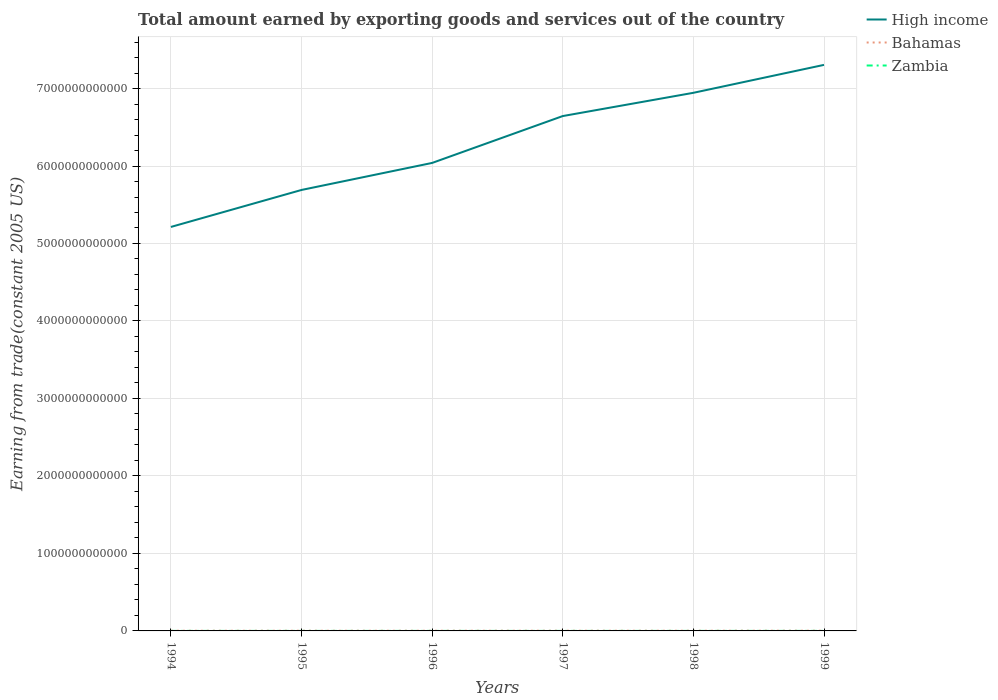Does the line corresponding to Bahamas intersect with the line corresponding to Zambia?
Provide a succinct answer. No. Is the number of lines equal to the number of legend labels?
Your response must be concise. Yes. Across all years, what is the maximum total amount earned by exporting goods and services in Zambia?
Ensure brevity in your answer.  1.79e+08. What is the total total amount earned by exporting goods and services in Bahamas in the graph?
Your response must be concise. -5.04e+08. What is the difference between the highest and the second highest total amount earned by exporting goods and services in Zambia?
Give a very brief answer. 2.86e+08. Is the total amount earned by exporting goods and services in Bahamas strictly greater than the total amount earned by exporting goods and services in Zambia over the years?
Offer a terse response. No. How many years are there in the graph?
Keep it short and to the point. 6. What is the difference between two consecutive major ticks on the Y-axis?
Provide a short and direct response. 1.00e+12. Are the values on the major ticks of Y-axis written in scientific E-notation?
Offer a terse response. No. Does the graph contain any zero values?
Provide a short and direct response. No. Does the graph contain grids?
Ensure brevity in your answer.  Yes. Where does the legend appear in the graph?
Ensure brevity in your answer.  Top right. How are the legend labels stacked?
Make the answer very short. Vertical. What is the title of the graph?
Offer a very short reply. Total amount earned by exporting goods and services out of the country. What is the label or title of the X-axis?
Your response must be concise. Years. What is the label or title of the Y-axis?
Offer a very short reply. Earning from trade(constant 2005 US). What is the Earning from trade(constant 2005 US) of High income in 1994?
Ensure brevity in your answer.  5.21e+12. What is the Earning from trade(constant 2005 US) in Bahamas in 1994?
Give a very brief answer. 2.35e+09. What is the Earning from trade(constant 2005 US) in Zambia in 1994?
Your answer should be compact. 2.00e+08. What is the Earning from trade(constant 2005 US) in High income in 1995?
Keep it short and to the point. 5.69e+12. What is the Earning from trade(constant 2005 US) of Bahamas in 1995?
Provide a succinct answer. 2.41e+09. What is the Earning from trade(constant 2005 US) of Zambia in 1995?
Provide a short and direct response. 1.79e+08. What is the Earning from trade(constant 2005 US) of High income in 1996?
Keep it short and to the point. 6.04e+12. What is the Earning from trade(constant 2005 US) in Bahamas in 1996?
Your answer should be compact. 2.50e+09. What is the Earning from trade(constant 2005 US) of Zambia in 1996?
Offer a very short reply. 2.01e+08. What is the Earning from trade(constant 2005 US) in High income in 1997?
Ensure brevity in your answer.  6.64e+12. What is the Earning from trade(constant 2005 US) in Bahamas in 1997?
Offer a terse response. 2.71e+09. What is the Earning from trade(constant 2005 US) of Zambia in 1997?
Your response must be concise. 2.37e+08. What is the Earning from trade(constant 2005 US) in High income in 1998?
Give a very brief answer. 6.94e+12. What is the Earning from trade(constant 2005 US) of Bahamas in 1998?
Offer a very short reply. 2.68e+09. What is the Earning from trade(constant 2005 US) of Zambia in 1998?
Offer a very short reply. 2.49e+08. What is the Earning from trade(constant 2005 US) in High income in 1999?
Your response must be concise. 7.31e+12. What is the Earning from trade(constant 2005 US) in Bahamas in 1999?
Make the answer very short. 2.85e+09. What is the Earning from trade(constant 2005 US) in Zambia in 1999?
Give a very brief answer. 4.66e+08. Across all years, what is the maximum Earning from trade(constant 2005 US) in High income?
Your answer should be compact. 7.31e+12. Across all years, what is the maximum Earning from trade(constant 2005 US) of Bahamas?
Provide a short and direct response. 2.85e+09. Across all years, what is the maximum Earning from trade(constant 2005 US) of Zambia?
Offer a very short reply. 4.66e+08. Across all years, what is the minimum Earning from trade(constant 2005 US) in High income?
Keep it short and to the point. 5.21e+12. Across all years, what is the minimum Earning from trade(constant 2005 US) in Bahamas?
Give a very brief answer. 2.35e+09. Across all years, what is the minimum Earning from trade(constant 2005 US) in Zambia?
Your response must be concise. 1.79e+08. What is the total Earning from trade(constant 2005 US) in High income in the graph?
Make the answer very short. 3.78e+13. What is the total Earning from trade(constant 2005 US) of Bahamas in the graph?
Keep it short and to the point. 1.55e+1. What is the total Earning from trade(constant 2005 US) of Zambia in the graph?
Your answer should be compact. 1.53e+09. What is the difference between the Earning from trade(constant 2005 US) in High income in 1994 and that in 1995?
Your answer should be very brief. -4.77e+11. What is the difference between the Earning from trade(constant 2005 US) in Bahamas in 1994 and that in 1995?
Your response must be concise. -6.07e+07. What is the difference between the Earning from trade(constant 2005 US) in Zambia in 1994 and that in 1995?
Provide a short and direct response. 2.11e+07. What is the difference between the Earning from trade(constant 2005 US) of High income in 1994 and that in 1996?
Provide a short and direct response. -8.26e+11. What is the difference between the Earning from trade(constant 2005 US) in Bahamas in 1994 and that in 1996?
Your answer should be compact. -1.48e+08. What is the difference between the Earning from trade(constant 2005 US) in Zambia in 1994 and that in 1996?
Provide a succinct answer. -4.14e+05. What is the difference between the Earning from trade(constant 2005 US) of High income in 1994 and that in 1997?
Offer a very short reply. -1.43e+12. What is the difference between the Earning from trade(constant 2005 US) in Bahamas in 1994 and that in 1997?
Give a very brief answer. -3.59e+08. What is the difference between the Earning from trade(constant 2005 US) in Zambia in 1994 and that in 1997?
Offer a very short reply. -3.68e+07. What is the difference between the Earning from trade(constant 2005 US) in High income in 1994 and that in 1998?
Provide a succinct answer. -1.73e+12. What is the difference between the Earning from trade(constant 2005 US) in Bahamas in 1994 and that in 1998?
Provide a short and direct response. -3.25e+08. What is the difference between the Earning from trade(constant 2005 US) of Zambia in 1994 and that in 1998?
Offer a very short reply. -4.81e+07. What is the difference between the Earning from trade(constant 2005 US) in High income in 1994 and that in 1999?
Offer a terse response. -2.09e+12. What is the difference between the Earning from trade(constant 2005 US) of Bahamas in 1994 and that in 1999?
Make the answer very short. -5.04e+08. What is the difference between the Earning from trade(constant 2005 US) in Zambia in 1994 and that in 1999?
Give a very brief answer. -2.65e+08. What is the difference between the Earning from trade(constant 2005 US) of High income in 1995 and that in 1996?
Your answer should be very brief. -3.49e+11. What is the difference between the Earning from trade(constant 2005 US) of Bahamas in 1995 and that in 1996?
Offer a terse response. -8.72e+07. What is the difference between the Earning from trade(constant 2005 US) of Zambia in 1995 and that in 1996?
Provide a short and direct response. -2.15e+07. What is the difference between the Earning from trade(constant 2005 US) in High income in 1995 and that in 1997?
Provide a short and direct response. -9.54e+11. What is the difference between the Earning from trade(constant 2005 US) of Bahamas in 1995 and that in 1997?
Ensure brevity in your answer.  -2.98e+08. What is the difference between the Earning from trade(constant 2005 US) in Zambia in 1995 and that in 1997?
Make the answer very short. -5.79e+07. What is the difference between the Earning from trade(constant 2005 US) in High income in 1995 and that in 1998?
Provide a short and direct response. -1.25e+12. What is the difference between the Earning from trade(constant 2005 US) in Bahamas in 1995 and that in 1998?
Your response must be concise. -2.65e+08. What is the difference between the Earning from trade(constant 2005 US) in Zambia in 1995 and that in 1998?
Your answer should be very brief. -6.91e+07. What is the difference between the Earning from trade(constant 2005 US) of High income in 1995 and that in 1999?
Provide a short and direct response. -1.61e+12. What is the difference between the Earning from trade(constant 2005 US) in Bahamas in 1995 and that in 1999?
Your answer should be very brief. -4.43e+08. What is the difference between the Earning from trade(constant 2005 US) of Zambia in 1995 and that in 1999?
Your answer should be very brief. -2.86e+08. What is the difference between the Earning from trade(constant 2005 US) in High income in 1996 and that in 1997?
Keep it short and to the point. -6.05e+11. What is the difference between the Earning from trade(constant 2005 US) of Bahamas in 1996 and that in 1997?
Provide a short and direct response. -2.11e+08. What is the difference between the Earning from trade(constant 2005 US) of Zambia in 1996 and that in 1997?
Provide a succinct answer. -3.64e+07. What is the difference between the Earning from trade(constant 2005 US) of High income in 1996 and that in 1998?
Your answer should be compact. -9.05e+11. What is the difference between the Earning from trade(constant 2005 US) in Bahamas in 1996 and that in 1998?
Offer a terse response. -1.78e+08. What is the difference between the Earning from trade(constant 2005 US) in Zambia in 1996 and that in 1998?
Keep it short and to the point. -4.77e+07. What is the difference between the Earning from trade(constant 2005 US) of High income in 1996 and that in 1999?
Provide a short and direct response. -1.27e+12. What is the difference between the Earning from trade(constant 2005 US) in Bahamas in 1996 and that in 1999?
Your response must be concise. -3.56e+08. What is the difference between the Earning from trade(constant 2005 US) in Zambia in 1996 and that in 1999?
Provide a succinct answer. -2.65e+08. What is the difference between the Earning from trade(constant 2005 US) of High income in 1997 and that in 1998?
Your answer should be very brief. -3.00e+11. What is the difference between the Earning from trade(constant 2005 US) in Bahamas in 1997 and that in 1998?
Provide a succinct answer. 3.35e+07. What is the difference between the Earning from trade(constant 2005 US) of Zambia in 1997 and that in 1998?
Ensure brevity in your answer.  -1.12e+07. What is the difference between the Earning from trade(constant 2005 US) in High income in 1997 and that in 1999?
Make the answer very short. -6.61e+11. What is the difference between the Earning from trade(constant 2005 US) in Bahamas in 1997 and that in 1999?
Give a very brief answer. -1.45e+08. What is the difference between the Earning from trade(constant 2005 US) in Zambia in 1997 and that in 1999?
Give a very brief answer. -2.29e+08. What is the difference between the Earning from trade(constant 2005 US) in High income in 1998 and that in 1999?
Your answer should be compact. -3.60e+11. What is the difference between the Earning from trade(constant 2005 US) of Bahamas in 1998 and that in 1999?
Provide a succinct answer. -1.79e+08. What is the difference between the Earning from trade(constant 2005 US) of Zambia in 1998 and that in 1999?
Keep it short and to the point. -2.17e+08. What is the difference between the Earning from trade(constant 2005 US) in High income in 1994 and the Earning from trade(constant 2005 US) in Bahamas in 1995?
Make the answer very short. 5.21e+12. What is the difference between the Earning from trade(constant 2005 US) in High income in 1994 and the Earning from trade(constant 2005 US) in Zambia in 1995?
Your answer should be compact. 5.21e+12. What is the difference between the Earning from trade(constant 2005 US) in Bahamas in 1994 and the Earning from trade(constant 2005 US) in Zambia in 1995?
Give a very brief answer. 2.17e+09. What is the difference between the Earning from trade(constant 2005 US) of High income in 1994 and the Earning from trade(constant 2005 US) of Bahamas in 1996?
Keep it short and to the point. 5.21e+12. What is the difference between the Earning from trade(constant 2005 US) in High income in 1994 and the Earning from trade(constant 2005 US) in Zambia in 1996?
Provide a succinct answer. 5.21e+12. What is the difference between the Earning from trade(constant 2005 US) in Bahamas in 1994 and the Earning from trade(constant 2005 US) in Zambia in 1996?
Offer a terse response. 2.15e+09. What is the difference between the Earning from trade(constant 2005 US) of High income in 1994 and the Earning from trade(constant 2005 US) of Bahamas in 1997?
Your answer should be compact. 5.21e+12. What is the difference between the Earning from trade(constant 2005 US) in High income in 1994 and the Earning from trade(constant 2005 US) in Zambia in 1997?
Offer a terse response. 5.21e+12. What is the difference between the Earning from trade(constant 2005 US) of Bahamas in 1994 and the Earning from trade(constant 2005 US) of Zambia in 1997?
Give a very brief answer. 2.11e+09. What is the difference between the Earning from trade(constant 2005 US) in High income in 1994 and the Earning from trade(constant 2005 US) in Bahamas in 1998?
Your response must be concise. 5.21e+12. What is the difference between the Earning from trade(constant 2005 US) in High income in 1994 and the Earning from trade(constant 2005 US) in Zambia in 1998?
Provide a short and direct response. 5.21e+12. What is the difference between the Earning from trade(constant 2005 US) of Bahamas in 1994 and the Earning from trade(constant 2005 US) of Zambia in 1998?
Your answer should be very brief. 2.10e+09. What is the difference between the Earning from trade(constant 2005 US) of High income in 1994 and the Earning from trade(constant 2005 US) of Bahamas in 1999?
Your answer should be very brief. 5.21e+12. What is the difference between the Earning from trade(constant 2005 US) in High income in 1994 and the Earning from trade(constant 2005 US) in Zambia in 1999?
Offer a terse response. 5.21e+12. What is the difference between the Earning from trade(constant 2005 US) in Bahamas in 1994 and the Earning from trade(constant 2005 US) in Zambia in 1999?
Your response must be concise. 1.88e+09. What is the difference between the Earning from trade(constant 2005 US) in High income in 1995 and the Earning from trade(constant 2005 US) in Bahamas in 1996?
Your response must be concise. 5.69e+12. What is the difference between the Earning from trade(constant 2005 US) in High income in 1995 and the Earning from trade(constant 2005 US) in Zambia in 1996?
Your answer should be compact. 5.69e+12. What is the difference between the Earning from trade(constant 2005 US) of Bahamas in 1995 and the Earning from trade(constant 2005 US) of Zambia in 1996?
Provide a short and direct response. 2.21e+09. What is the difference between the Earning from trade(constant 2005 US) in High income in 1995 and the Earning from trade(constant 2005 US) in Bahamas in 1997?
Offer a terse response. 5.69e+12. What is the difference between the Earning from trade(constant 2005 US) of High income in 1995 and the Earning from trade(constant 2005 US) of Zambia in 1997?
Give a very brief answer. 5.69e+12. What is the difference between the Earning from trade(constant 2005 US) in Bahamas in 1995 and the Earning from trade(constant 2005 US) in Zambia in 1997?
Your answer should be compact. 2.17e+09. What is the difference between the Earning from trade(constant 2005 US) of High income in 1995 and the Earning from trade(constant 2005 US) of Bahamas in 1998?
Offer a very short reply. 5.69e+12. What is the difference between the Earning from trade(constant 2005 US) of High income in 1995 and the Earning from trade(constant 2005 US) of Zambia in 1998?
Give a very brief answer. 5.69e+12. What is the difference between the Earning from trade(constant 2005 US) in Bahamas in 1995 and the Earning from trade(constant 2005 US) in Zambia in 1998?
Keep it short and to the point. 2.16e+09. What is the difference between the Earning from trade(constant 2005 US) of High income in 1995 and the Earning from trade(constant 2005 US) of Bahamas in 1999?
Give a very brief answer. 5.69e+12. What is the difference between the Earning from trade(constant 2005 US) in High income in 1995 and the Earning from trade(constant 2005 US) in Zambia in 1999?
Your answer should be compact. 5.69e+12. What is the difference between the Earning from trade(constant 2005 US) of Bahamas in 1995 and the Earning from trade(constant 2005 US) of Zambia in 1999?
Ensure brevity in your answer.  1.95e+09. What is the difference between the Earning from trade(constant 2005 US) in High income in 1996 and the Earning from trade(constant 2005 US) in Bahamas in 1997?
Keep it short and to the point. 6.04e+12. What is the difference between the Earning from trade(constant 2005 US) of High income in 1996 and the Earning from trade(constant 2005 US) of Zambia in 1997?
Keep it short and to the point. 6.04e+12. What is the difference between the Earning from trade(constant 2005 US) in Bahamas in 1996 and the Earning from trade(constant 2005 US) in Zambia in 1997?
Provide a succinct answer. 2.26e+09. What is the difference between the Earning from trade(constant 2005 US) in High income in 1996 and the Earning from trade(constant 2005 US) in Bahamas in 1998?
Offer a very short reply. 6.04e+12. What is the difference between the Earning from trade(constant 2005 US) in High income in 1996 and the Earning from trade(constant 2005 US) in Zambia in 1998?
Ensure brevity in your answer.  6.04e+12. What is the difference between the Earning from trade(constant 2005 US) of Bahamas in 1996 and the Earning from trade(constant 2005 US) of Zambia in 1998?
Ensure brevity in your answer.  2.25e+09. What is the difference between the Earning from trade(constant 2005 US) of High income in 1996 and the Earning from trade(constant 2005 US) of Bahamas in 1999?
Provide a short and direct response. 6.04e+12. What is the difference between the Earning from trade(constant 2005 US) in High income in 1996 and the Earning from trade(constant 2005 US) in Zambia in 1999?
Your answer should be very brief. 6.04e+12. What is the difference between the Earning from trade(constant 2005 US) in Bahamas in 1996 and the Earning from trade(constant 2005 US) in Zambia in 1999?
Your response must be concise. 2.03e+09. What is the difference between the Earning from trade(constant 2005 US) of High income in 1997 and the Earning from trade(constant 2005 US) of Bahamas in 1998?
Your answer should be very brief. 6.64e+12. What is the difference between the Earning from trade(constant 2005 US) in High income in 1997 and the Earning from trade(constant 2005 US) in Zambia in 1998?
Make the answer very short. 6.64e+12. What is the difference between the Earning from trade(constant 2005 US) of Bahamas in 1997 and the Earning from trade(constant 2005 US) of Zambia in 1998?
Keep it short and to the point. 2.46e+09. What is the difference between the Earning from trade(constant 2005 US) in High income in 1997 and the Earning from trade(constant 2005 US) in Bahamas in 1999?
Your answer should be very brief. 6.64e+12. What is the difference between the Earning from trade(constant 2005 US) of High income in 1997 and the Earning from trade(constant 2005 US) of Zambia in 1999?
Provide a succinct answer. 6.64e+12. What is the difference between the Earning from trade(constant 2005 US) in Bahamas in 1997 and the Earning from trade(constant 2005 US) in Zambia in 1999?
Offer a terse response. 2.24e+09. What is the difference between the Earning from trade(constant 2005 US) in High income in 1998 and the Earning from trade(constant 2005 US) in Bahamas in 1999?
Make the answer very short. 6.94e+12. What is the difference between the Earning from trade(constant 2005 US) in High income in 1998 and the Earning from trade(constant 2005 US) in Zambia in 1999?
Give a very brief answer. 6.94e+12. What is the difference between the Earning from trade(constant 2005 US) of Bahamas in 1998 and the Earning from trade(constant 2005 US) of Zambia in 1999?
Provide a short and direct response. 2.21e+09. What is the average Earning from trade(constant 2005 US) in High income per year?
Your answer should be very brief. 6.31e+12. What is the average Earning from trade(constant 2005 US) of Bahamas per year?
Offer a terse response. 2.58e+09. What is the average Earning from trade(constant 2005 US) of Zambia per year?
Offer a terse response. 2.55e+08. In the year 1994, what is the difference between the Earning from trade(constant 2005 US) in High income and Earning from trade(constant 2005 US) in Bahamas?
Your answer should be very brief. 5.21e+12. In the year 1994, what is the difference between the Earning from trade(constant 2005 US) of High income and Earning from trade(constant 2005 US) of Zambia?
Your answer should be compact. 5.21e+12. In the year 1994, what is the difference between the Earning from trade(constant 2005 US) in Bahamas and Earning from trade(constant 2005 US) in Zambia?
Offer a very short reply. 2.15e+09. In the year 1995, what is the difference between the Earning from trade(constant 2005 US) of High income and Earning from trade(constant 2005 US) of Bahamas?
Offer a terse response. 5.69e+12. In the year 1995, what is the difference between the Earning from trade(constant 2005 US) of High income and Earning from trade(constant 2005 US) of Zambia?
Provide a short and direct response. 5.69e+12. In the year 1995, what is the difference between the Earning from trade(constant 2005 US) in Bahamas and Earning from trade(constant 2005 US) in Zambia?
Your answer should be compact. 2.23e+09. In the year 1996, what is the difference between the Earning from trade(constant 2005 US) in High income and Earning from trade(constant 2005 US) in Bahamas?
Your answer should be compact. 6.04e+12. In the year 1996, what is the difference between the Earning from trade(constant 2005 US) in High income and Earning from trade(constant 2005 US) in Zambia?
Your answer should be very brief. 6.04e+12. In the year 1996, what is the difference between the Earning from trade(constant 2005 US) in Bahamas and Earning from trade(constant 2005 US) in Zambia?
Your response must be concise. 2.30e+09. In the year 1997, what is the difference between the Earning from trade(constant 2005 US) in High income and Earning from trade(constant 2005 US) in Bahamas?
Keep it short and to the point. 6.64e+12. In the year 1997, what is the difference between the Earning from trade(constant 2005 US) of High income and Earning from trade(constant 2005 US) of Zambia?
Offer a very short reply. 6.64e+12. In the year 1997, what is the difference between the Earning from trade(constant 2005 US) of Bahamas and Earning from trade(constant 2005 US) of Zambia?
Your response must be concise. 2.47e+09. In the year 1998, what is the difference between the Earning from trade(constant 2005 US) in High income and Earning from trade(constant 2005 US) in Bahamas?
Your response must be concise. 6.94e+12. In the year 1998, what is the difference between the Earning from trade(constant 2005 US) in High income and Earning from trade(constant 2005 US) in Zambia?
Provide a succinct answer. 6.94e+12. In the year 1998, what is the difference between the Earning from trade(constant 2005 US) of Bahamas and Earning from trade(constant 2005 US) of Zambia?
Offer a terse response. 2.43e+09. In the year 1999, what is the difference between the Earning from trade(constant 2005 US) of High income and Earning from trade(constant 2005 US) of Bahamas?
Your response must be concise. 7.30e+12. In the year 1999, what is the difference between the Earning from trade(constant 2005 US) of High income and Earning from trade(constant 2005 US) of Zambia?
Ensure brevity in your answer.  7.30e+12. In the year 1999, what is the difference between the Earning from trade(constant 2005 US) of Bahamas and Earning from trade(constant 2005 US) of Zambia?
Your response must be concise. 2.39e+09. What is the ratio of the Earning from trade(constant 2005 US) in High income in 1994 to that in 1995?
Your answer should be very brief. 0.92. What is the ratio of the Earning from trade(constant 2005 US) of Bahamas in 1994 to that in 1995?
Offer a terse response. 0.97. What is the ratio of the Earning from trade(constant 2005 US) of Zambia in 1994 to that in 1995?
Your response must be concise. 1.12. What is the ratio of the Earning from trade(constant 2005 US) in High income in 1994 to that in 1996?
Ensure brevity in your answer.  0.86. What is the ratio of the Earning from trade(constant 2005 US) in Bahamas in 1994 to that in 1996?
Offer a terse response. 0.94. What is the ratio of the Earning from trade(constant 2005 US) of Zambia in 1994 to that in 1996?
Your answer should be compact. 1. What is the ratio of the Earning from trade(constant 2005 US) of High income in 1994 to that in 1997?
Your answer should be very brief. 0.78. What is the ratio of the Earning from trade(constant 2005 US) of Bahamas in 1994 to that in 1997?
Keep it short and to the point. 0.87. What is the ratio of the Earning from trade(constant 2005 US) of Zambia in 1994 to that in 1997?
Make the answer very short. 0.84. What is the ratio of the Earning from trade(constant 2005 US) of High income in 1994 to that in 1998?
Your response must be concise. 0.75. What is the ratio of the Earning from trade(constant 2005 US) of Bahamas in 1994 to that in 1998?
Your answer should be compact. 0.88. What is the ratio of the Earning from trade(constant 2005 US) of Zambia in 1994 to that in 1998?
Your answer should be compact. 0.81. What is the ratio of the Earning from trade(constant 2005 US) in High income in 1994 to that in 1999?
Offer a very short reply. 0.71. What is the ratio of the Earning from trade(constant 2005 US) of Bahamas in 1994 to that in 1999?
Keep it short and to the point. 0.82. What is the ratio of the Earning from trade(constant 2005 US) of Zambia in 1994 to that in 1999?
Ensure brevity in your answer.  0.43. What is the ratio of the Earning from trade(constant 2005 US) of High income in 1995 to that in 1996?
Your response must be concise. 0.94. What is the ratio of the Earning from trade(constant 2005 US) in Bahamas in 1995 to that in 1996?
Make the answer very short. 0.97. What is the ratio of the Earning from trade(constant 2005 US) in Zambia in 1995 to that in 1996?
Provide a succinct answer. 0.89. What is the ratio of the Earning from trade(constant 2005 US) of High income in 1995 to that in 1997?
Your response must be concise. 0.86. What is the ratio of the Earning from trade(constant 2005 US) of Bahamas in 1995 to that in 1997?
Keep it short and to the point. 0.89. What is the ratio of the Earning from trade(constant 2005 US) in Zambia in 1995 to that in 1997?
Give a very brief answer. 0.76. What is the ratio of the Earning from trade(constant 2005 US) in High income in 1995 to that in 1998?
Give a very brief answer. 0.82. What is the ratio of the Earning from trade(constant 2005 US) in Bahamas in 1995 to that in 1998?
Your response must be concise. 0.9. What is the ratio of the Earning from trade(constant 2005 US) of Zambia in 1995 to that in 1998?
Provide a short and direct response. 0.72. What is the ratio of the Earning from trade(constant 2005 US) of High income in 1995 to that in 1999?
Offer a very short reply. 0.78. What is the ratio of the Earning from trade(constant 2005 US) in Bahamas in 1995 to that in 1999?
Your response must be concise. 0.84. What is the ratio of the Earning from trade(constant 2005 US) in Zambia in 1995 to that in 1999?
Offer a very short reply. 0.39. What is the ratio of the Earning from trade(constant 2005 US) in High income in 1996 to that in 1997?
Keep it short and to the point. 0.91. What is the ratio of the Earning from trade(constant 2005 US) in Bahamas in 1996 to that in 1997?
Your answer should be compact. 0.92. What is the ratio of the Earning from trade(constant 2005 US) in Zambia in 1996 to that in 1997?
Keep it short and to the point. 0.85. What is the ratio of the Earning from trade(constant 2005 US) of High income in 1996 to that in 1998?
Your answer should be very brief. 0.87. What is the ratio of the Earning from trade(constant 2005 US) in Bahamas in 1996 to that in 1998?
Make the answer very short. 0.93. What is the ratio of the Earning from trade(constant 2005 US) of Zambia in 1996 to that in 1998?
Your answer should be compact. 0.81. What is the ratio of the Earning from trade(constant 2005 US) of High income in 1996 to that in 1999?
Offer a very short reply. 0.83. What is the ratio of the Earning from trade(constant 2005 US) of Bahamas in 1996 to that in 1999?
Give a very brief answer. 0.88. What is the ratio of the Earning from trade(constant 2005 US) in Zambia in 1996 to that in 1999?
Make the answer very short. 0.43. What is the ratio of the Earning from trade(constant 2005 US) of High income in 1997 to that in 1998?
Your answer should be very brief. 0.96. What is the ratio of the Earning from trade(constant 2005 US) in Bahamas in 1997 to that in 1998?
Give a very brief answer. 1.01. What is the ratio of the Earning from trade(constant 2005 US) of Zambia in 1997 to that in 1998?
Keep it short and to the point. 0.95. What is the ratio of the Earning from trade(constant 2005 US) in High income in 1997 to that in 1999?
Provide a succinct answer. 0.91. What is the ratio of the Earning from trade(constant 2005 US) in Bahamas in 1997 to that in 1999?
Your answer should be compact. 0.95. What is the ratio of the Earning from trade(constant 2005 US) in Zambia in 1997 to that in 1999?
Provide a succinct answer. 0.51. What is the ratio of the Earning from trade(constant 2005 US) of High income in 1998 to that in 1999?
Make the answer very short. 0.95. What is the ratio of the Earning from trade(constant 2005 US) in Bahamas in 1998 to that in 1999?
Keep it short and to the point. 0.94. What is the ratio of the Earning from trade(constant 2005 US) of Zambia in 1998 to that in 1999?
Provide a short and direct response. 0.53. What is the difference between the highest and the second highest Earning from trade(constant 2005 US) in High income?
Keep it short and to the point. 3.60e+11. What is the difference between the highest and the second highest Earning from trade(constant 2005 US) in Bahamas?
Keep it short and to the point. 1.45e+08. What is the difference between the highest and the second highest Earning from trade(constant 2005 US) in Zambia?
Provide a short and direct response. 2.17e+08. What is the difference between the highest and the lowest Earning from trade(constant 2005 US) of High income?
Your response must be concise. 2.09e+12. What is the difference between the highest and the lowest Earning from trade(constant 2005 US) in Bahamas?
Give a very brief answer. 5.04e+08. What is the difference between the highest and the lowest Earning from trade(constant 2005 US) of Zambia?
Your answer should be very brief. 2.86e+08. 